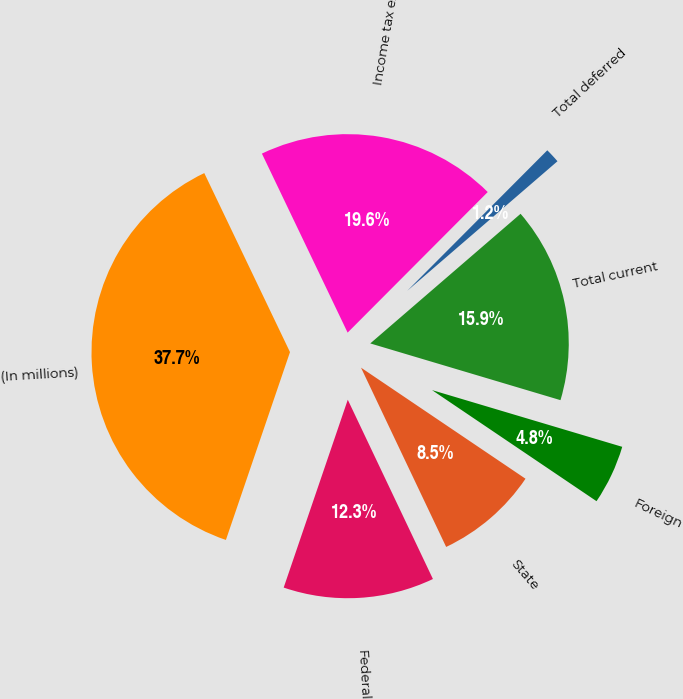Convert chart to OTSL. <chart><loc_0><loc_0><loc_500><loc_500><pie_chart><fcel>(In millions)<fcel>Federal<fcel>State<fcel>Foreign<fcel>Total current<fcel>Total deferred<fcel>Income tax expense<nl><fcel>37.66%<fcel>12.29%<fcel>8.49%<fcel>4.84%<fcel>15.94%<fcel>1.2%<fcel>19.58%<nl></chart> 